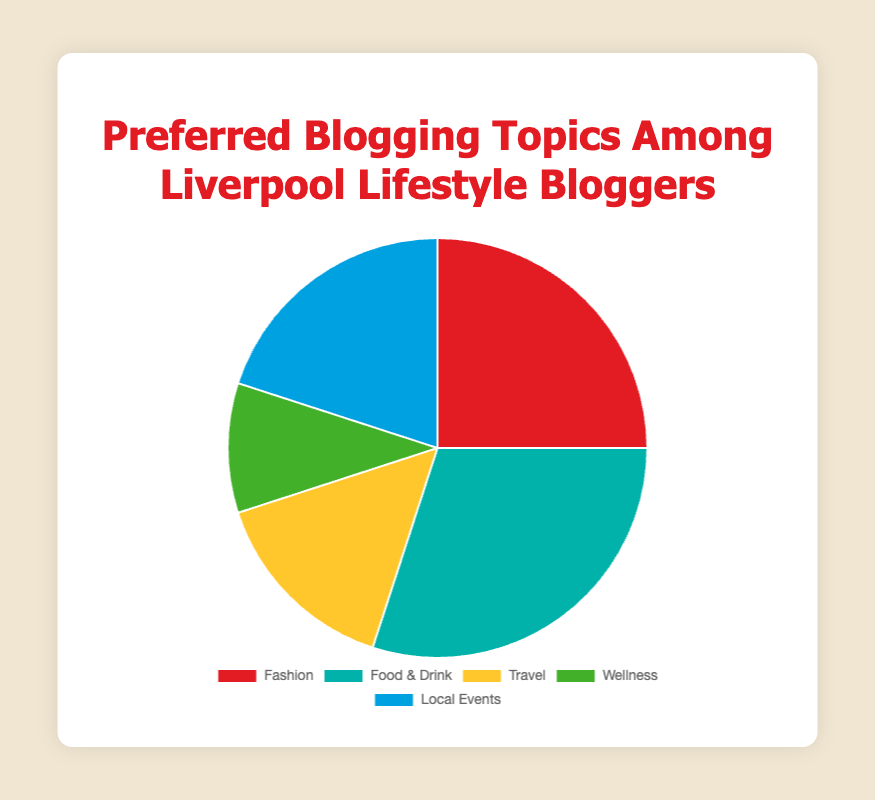Which blogging topic is the most popular? The "Food & Drink" category is the most popular, represented by the largest segment of the pie chart, which is labeled with a percentage of 30%.
Answer: Food & Drink Which category has the smallest percentage of preference among Liverpool lifestyle bloggers? The "Wellness" category has the smallest percentage, indicated by the smallest segment of the pie chart, which is labeled with a percentage of 10%.
Answer: Wellness What is the combined preference percentage for "Travel" and "Wellness" topics? To find the combined percentage, add the two percentages together: 15% (Travel) + 10% (Wellness) = 25%.
Answer: 25% How much more popular is "Food & Drink" compared to "Wellness"? Subtract the percentage of "Wellness" from that of "Food & Drink": 30% (Food & Drink) - 10% (Wellness) = 20%.
Answer: 20% Which topic has a higher preference: "Local Events" or "Fashion"? "Food & Drink" has a higher percentage (30%) when compared to the "Fashion" category (25%).
Answer: Food & Drink What percentage of bloggers prefer topics other than "Food & Drink" and "Local Events"? Subtract the sum of the "Food & Drink" and "Local Events" percentages from 100%: 100% - (30% + 20%) = 50%.
Answer: 50% How does the preference for "Fashion" compare to that for "Travel"? The preference for "Fashion" is 25%, which is greater than the 15% preference for "Travel".
Answer: Fashion What is the average preference percentage across all five topics? Add all the percentages together and divide by the number of topics: (25% + 30% + 15% + 10% + 20%) / 5 = 20%.
Answer: 20% By how much does the "Local Events" percentage exceed the "Wellness" percentage? Subtract the "Wellness" percentage from the "Local Events" percentage: 20% - 10% = 10%.
Answer: 10% What percentage of bloggers prefer either "Fashion" or "Local Events"? Add the percentages for "Fashion" and "Local Events": 25% (Fashion) + 20% (Local Events) = 45%.
Answer: 45% 